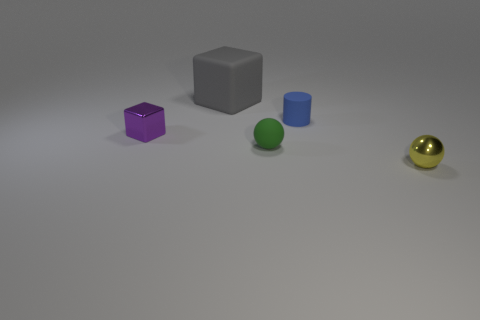Add 2 small green balls. How many objects exist? 7 Subtract all cylinders. How many objects are left? 4 Add 4 tiny yellow balls. How many tiny yellow balls exist? 5 Subtract 0 green cubes. How many objects are left? 5 Subtract all purple metal blocks. Subtract all blue rubber blocks. How many objects are left? 4 Add 4 small objects. How many small objects are left? 8 